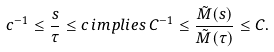Convert formula to latex. <formula><loc_0><loc_0><loc_500><loc_500>c ^ { - 1 } \leq \frac { s } { \tau } \leq c \, i m p l i e s \, C ^ { - 1 } \leq \frac { \tilde { M } ( s ) } { \tilde { M } ( \tau ) } \leq C .</formula> 